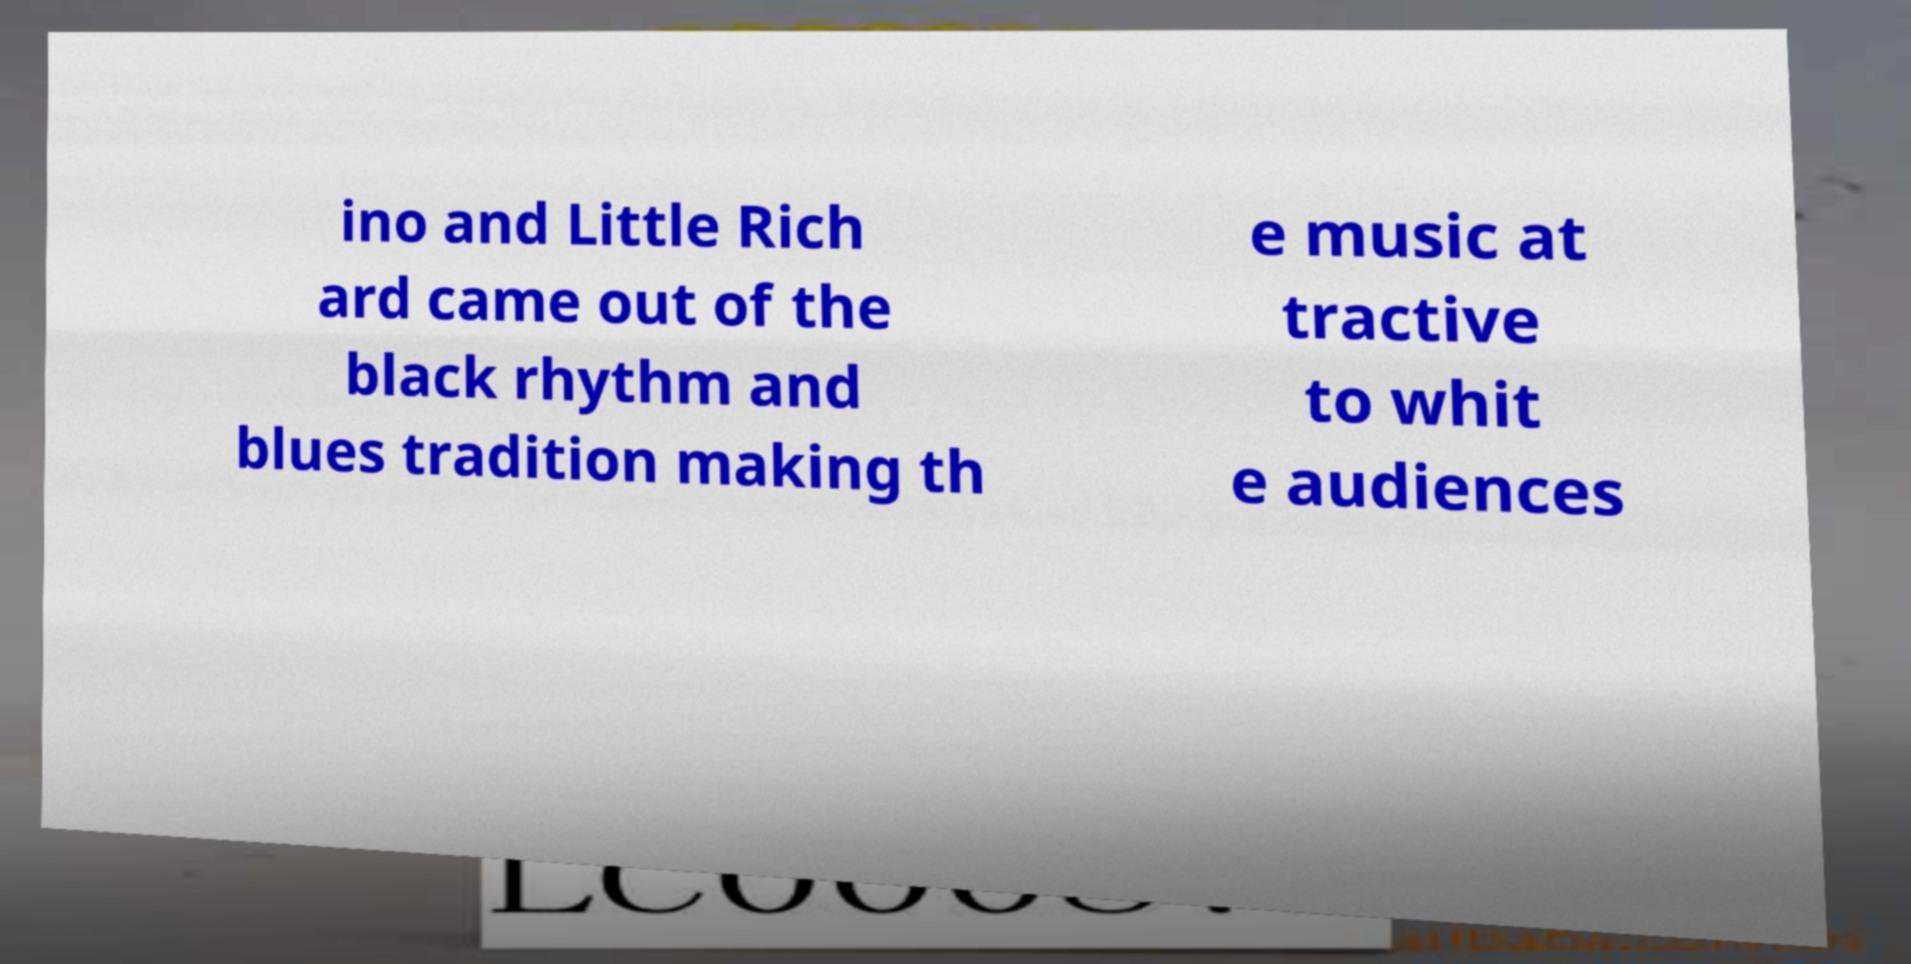Can you accurately transcribe the text from the provided image for me? ino and Little Rich ard came out of the black rhythm and blues tradition making th e music at tractive to whit e audiences 